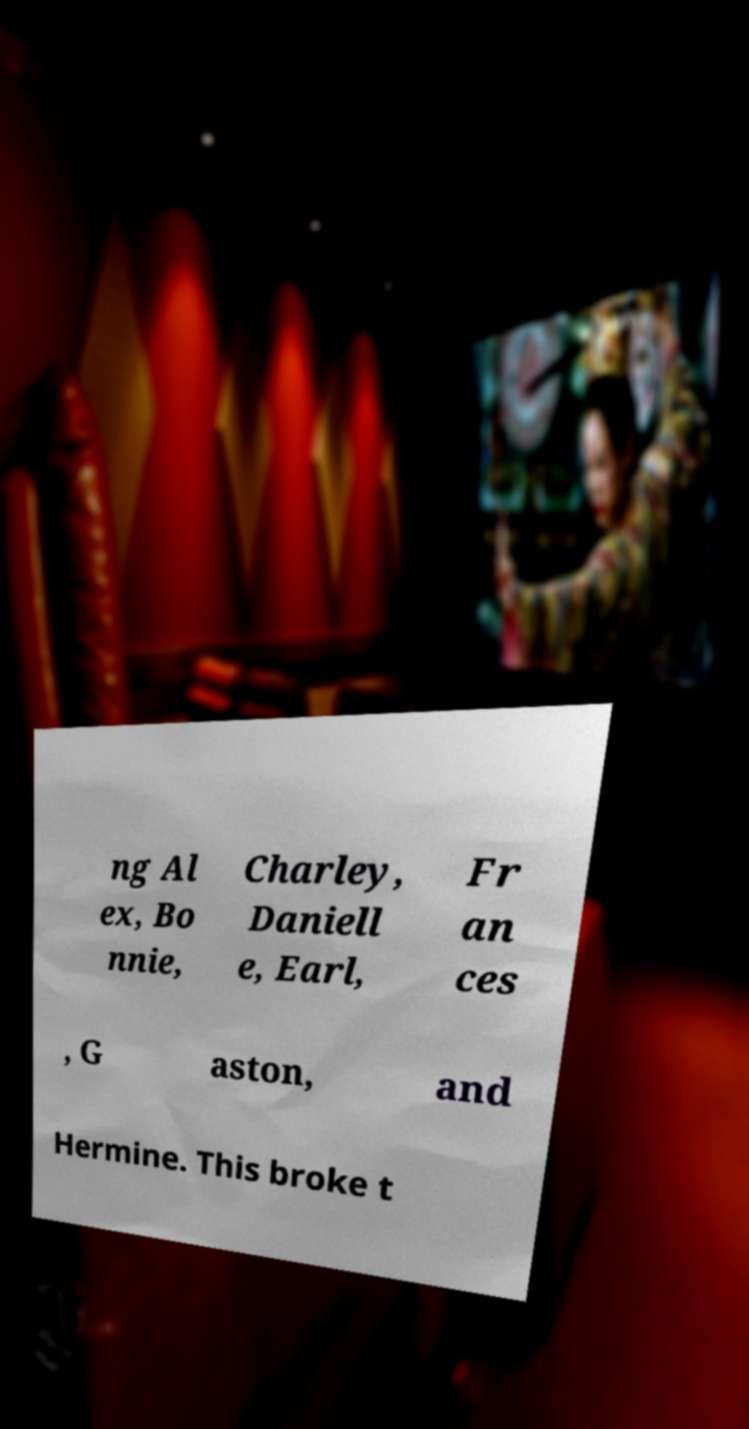Could you assist in decoding the text presented in this image and type it out clearly? ng Al ex, Bo nnie, Charley, Daniell e, Earl, Fr an ces , G aston, and Hermine. This broke t 